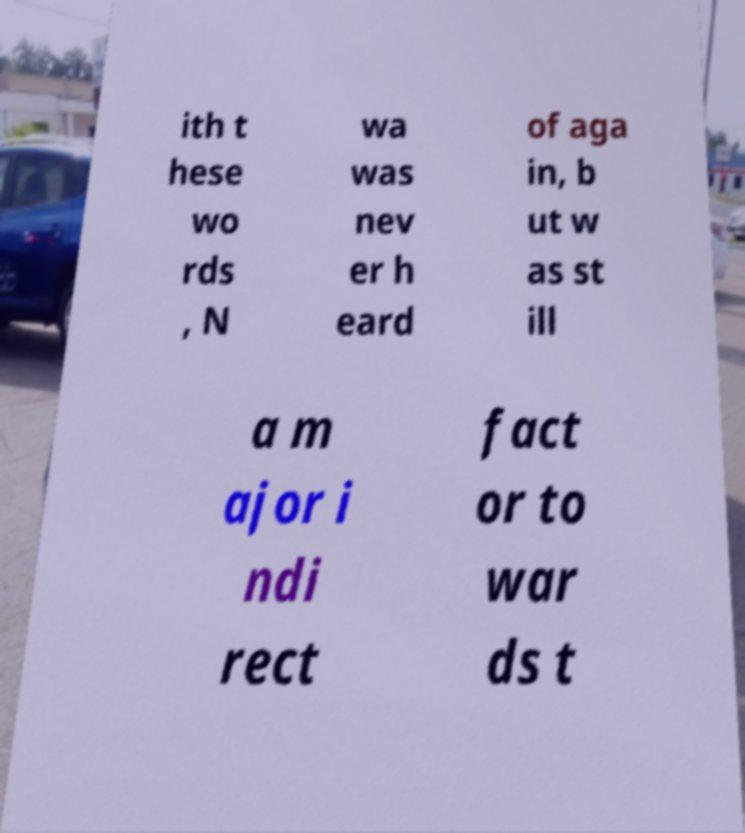Could you extract and type out the text from this image? ith t hese wo rds , N wa was nev er h eard of aga in, b ut w as st ill a m ajor i ndi rect fact or to war ds t 